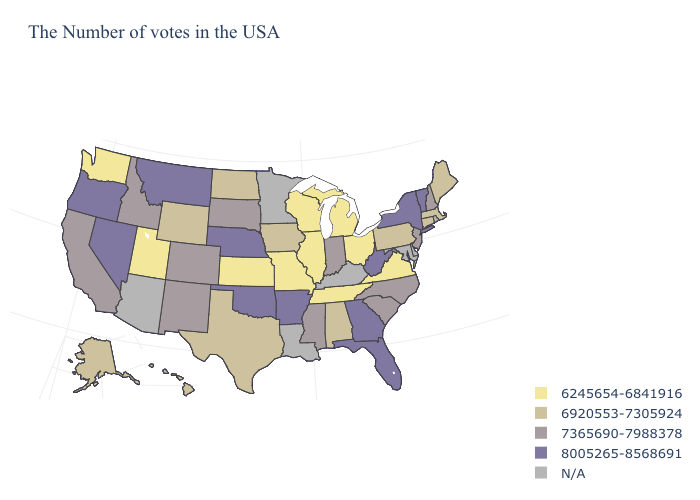Is the legend a continuous bar?
Write a very short answer. No. Name the states that have a value in the range 6920553-7305924?
Give a very brief answer. Maine, Massachusetts, Connecticut, Pennsylvania, Alabama, Iowa, Texas, North Dakota, Wyoming, Alaska, Hawaii. Among the states that border Missouri , does Illinois have the highest value?
Quick response, please. No. Among the states that border Ohio , which have the highest value?
Keep it brief. West Virginia. What is the lowest value in states that border Mississippi?
Keep it brief. 6245654-6841916. What is the value of South Carolina?
Give a very brief answer. 7365690-7988378. Does Ohio have the lowest value in the USA?
Quick response, please. Yes. What is the highest value in the MidWest ?
Short answer required. 8005265-8568691. What is the lowest value in the USA?
Write a very short answer. 6245654-6841916. What is the lowest value in the USA?
Answer briefly. 6245654-6841916. Which states hav the highest value in the MidWest?
Concise answer only. Nebraska. Does Virginia have the lowest value in the South?
Be succinct. Yes. 